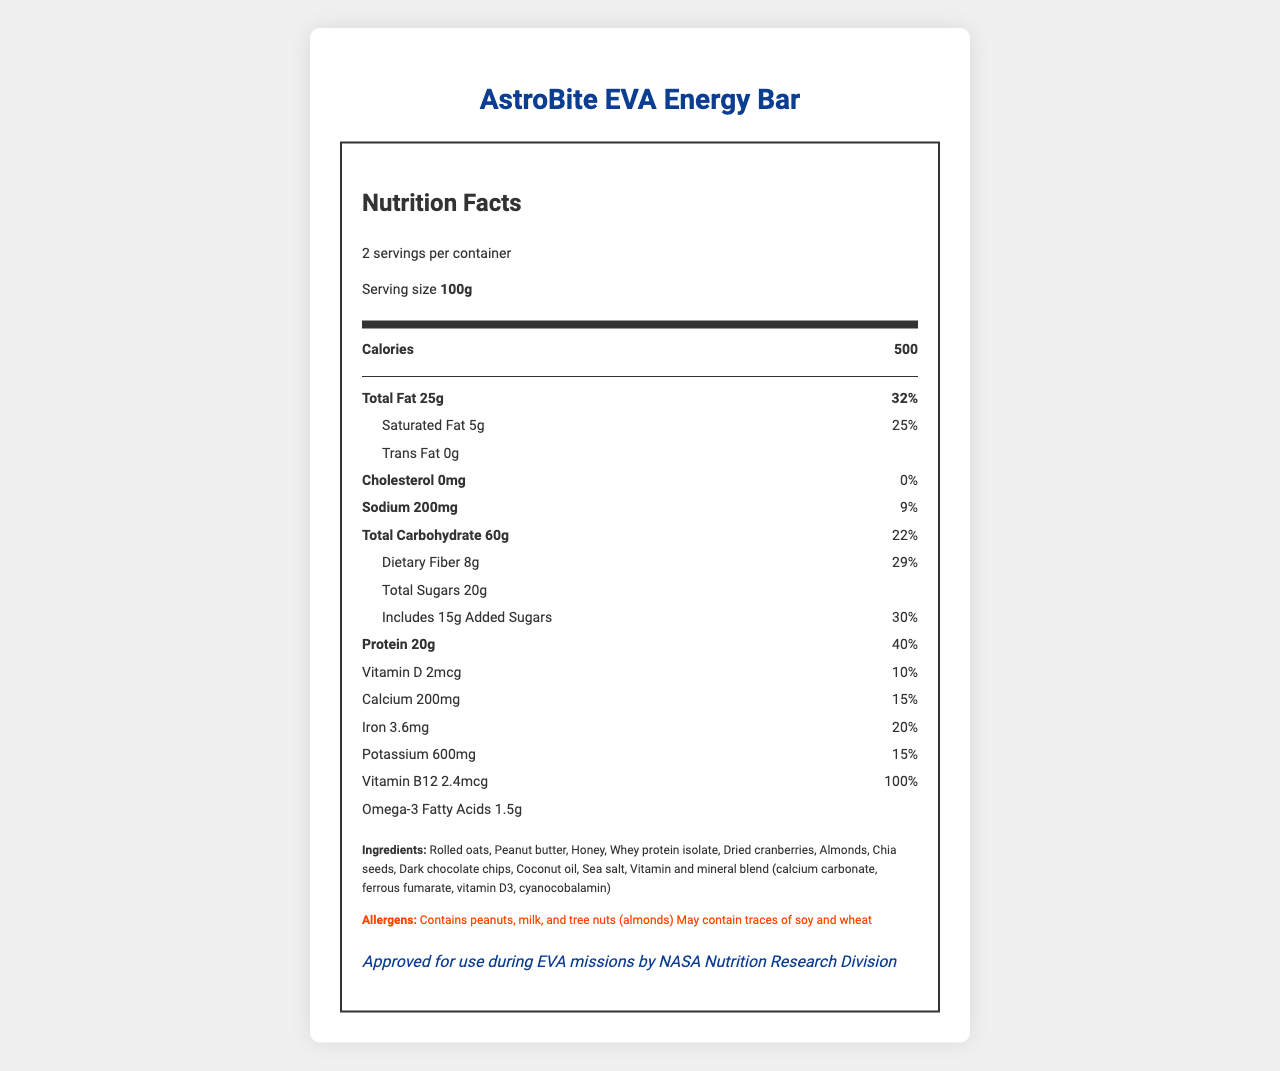what is the serving size of the AstroBite EVA Energy Bar? The serving size is mentioned at the beginning of the document under "Serving size."
Answer: 100g how many calories are in one serving of the energy bar? The document specifies that one serving of the bar contains 500 calories in the "Calories" section.
Answer: 500 what percent of the daily value is the total fat in one serving? Under the "Total Fat" section, it is stated that the total fat content amounts to 25g, which is 32% of the daily value.
Answer: 32% what is the amount of protein per serving, and what is its daily value percentage? The "Protein" section of the document lists 20g of protein per serving, which constitutes 40% of the daily value.
Answer: 20g, 40% how much dietary fiber does the energy bar contain per serving? The "Dietary Fiber" section indicates that each serving contains 8g of dietary fiber.
Answer: 8g which of the following nutrients is not present in the energy bar? A. Cholesterol B. Sodium C. Saturated Fat Under the "Cholesterol" section, it is stated that the bar contains 0mg of cholesterol, indicating its absence.
Answer: A what is the total carbohydrate content in one serving of the energy bar? A. 45g B. 60g C. 70g D. 50g The "Total Carbohydrate" section states that one serving contains 60g of carbohydrates.
Answer: B is the AstroBite EVA Energy Bar suitable for individuals with peanut allergies? The "Allergens" section clearly mentions that the bar contains peanuts.
Answer: No summarize the main information provided in the document. The document describes the nutrient content (calories, total fat, protein, etc.), ingredients, allergen information, storage instructions, and NASA's approval status for the energy bar.
Answer: The document provides detailed nutritional information about the AstroBite EVA Energy Bar, including calorie count, macronutrient, micronutrient content per serving, ingredient list, allergy information, and NASA's approval for use during EVA missions. how long is the energy bar safe for consumption after its production date? The "Storage instructions" section specifies that the bar should be consumed within 18 months of the production date.
Answer: 18 months what is the purpose of the AstroBite EVA Energy Bar according to the document? The document states that the bar was developed in collaboration with NASA to support long-duration space missions, including Mars missions, and contains nutrients vital for astronaut health.
Answer: To support long-duration space exploration and potential Mars missions, with enhanced nutrients essential for astronaut health. what is the name of the product? The product name is displayed prominently at the top of the document.
Answer: AstroBite EVA Energy Bar are omega-3 fatty acids present in the energy bar, and if so, what is their amount per serving? The section titled "Omega-3 Fatty Acids" indicates that each serving contains 1.5g of omega-3 fatty acids.
Answer: Yes, 1.5g what is the amount of added sugars in one serving? The "Added Sugars" section states that one serving includes 15g of added sugars.
Answer: 15g is the energy bar approved for use during extravehicular activities (EVAs)? The "nasa_approval" section mentions that the bar is approved for use during EVA missions by NASA.
Answer: Yes how much calcium is present in one serving of the AstroBite EVA Energy Bar in mg? The "Calcium" section specifies that one serving contains 200mg of calcium.
Answer: 200mg does the AstroBite EVA Energy Bar contain any vitamin B12, and if so, what is its daily value percentage? The "Vitamin B12" section shows that the bar has 2.4 mcg of vitamin B12, accounting for 100% of the daily value.
Answer: Yes, 100% why is the protein content significant for astronauts during EVAs? The document does not provide specific reasons for the importance of protein for astronauts during EVAs, so this cannot be determined directly from the visual information.
Answer: No answer provided. explain the net amount of sodium in both servings combined. Each serving contains 200mg of sodium, according to the document. Since there are 2 servings per container, the total amount of sodium is 200mg × 2 = 400mg.
Answer: 400mg 